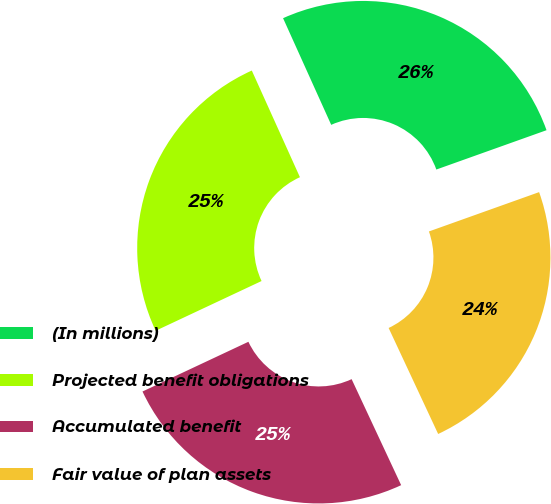Convert chart to OTSL. <chart><loc_0><loc_0><loc_500><loc_500><pie_chart><fcel>(In millions)<fcel>Projected benefit obligations<fcel>Accumulated benefit<fcel>Fair value of plan assets<nl><fcel>26.29%<fcel>25.24%<fcel>24.97%<fcel>23.5%<nl></chart> 